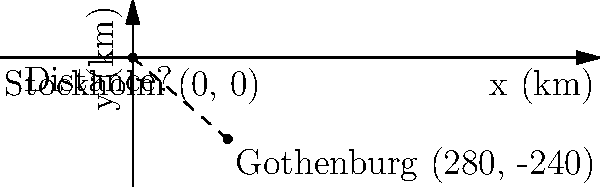You're planning a trip from Stockholm to Gothenburg. On a map of Sweden using a Cartesian coordinate system where Stockholm is at the origin (0, 0) and each unit represents 1 km, Gothenburg is located at coordinates (280, -240). Calculate the straight-line distance between these two cities in kilometers. To find the straight-line distance between Stockholm and Gothenburg, we can use the distance formula derived from the Pythagorean theorem:

1) The distance formula is: $d = \sqrt{(x_2 - x_1)^2 + (y_2 - y_1)^2}$

2) We have:
   Stockholm: $(x_1, y_1) = (0, 0)$
   Gothenburg: $(x_2, y_2) = (280, -240)$

3) Plugging these into the formula:
   $d = \sqrt{(280 - 0)^2 + (-240 - 0)^2}$

4) Simplify:
   $d = \sqrt{280^2 + (-240)^2}$

5) Calculate:
   $d = \sqrt{78,400 + 57,600}$
   $d = \sqrt{136,000}$

6) Simplify:
   $d = 368.78$ km (rounded to two decimal places)

Therefore, the straight-line distance between Stockholm and Gothenburg is approximately 368.78 km.
Answer: 368.78 km 